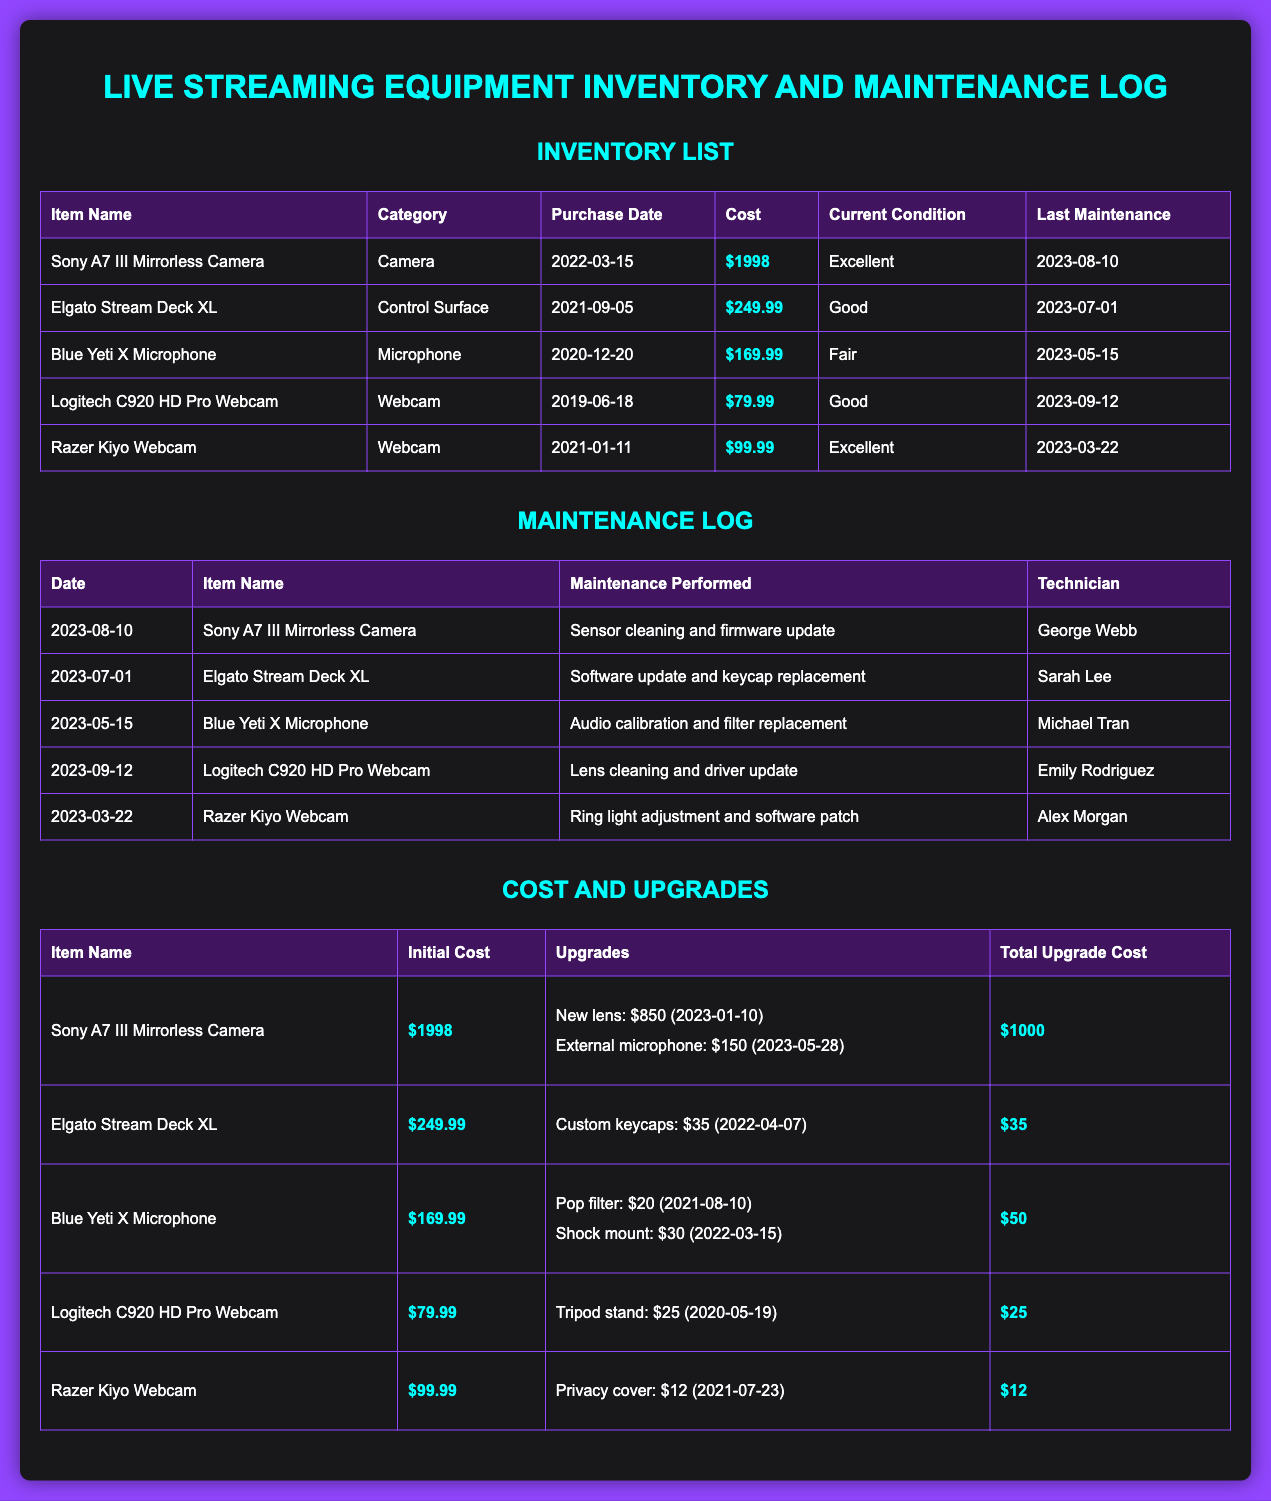What is the purchase date of the Sony A7 III? The purchase date in the inventory list for the Sony A7 III is specifically noted as 2022-03-15.
Answer: 2022-03-15 What is the cost of the Blue Yeti X Microphone? The cost of the Blue Yeti X Microphone is listed in the inventory table as $169.99.
Answer: $169.99 Which technician performed maintenance on the Logitech C920 HD Pro Webcam? The technician for the Logitech C920 HD Pro Webcam maintenance is mentioned as Emily Rodriguez in the maintenance log.
Answer: Emily Rodriguez What maintenance was performed on the Elgato Stream Deck XL? The maintenance log specifies that the maintenance performed on the Elgato Stream Deck XL included a software update and keycap replacement.
Answer: Software update and keycap replacement What is the total upgrade cost for the Sony A7 III? The total upgrade cost for the Sony A7 III is summarized as $1000 in the cost and upgrades section.
Answer: $1000 How many upgrades are listed for the Blue Yeti X Microphone? The cost and upgrades section lists two upgrades for the Blue Yeti X Microphone.
Answer: 2 What is the condition of the Razer Kiyo Webcam? The current condition of the Razer Kiyo Webcam is classified as Excellent in the inventory list.
Answer: Excellent What is the initial cost of the Elgato Stream Deck XL? The initial cost for the Elgato Stream Deck XL is stated as $249.99 in the cost and upgrades table.
Answer: $249.99 What date was the last maintenance for the Blue Yeti X Microphone? The last maintenance date recorded for the Blue Yeti X Microphone is noted as 2023-05-15 in the maintenance log.
Answer: 2023-05-15 